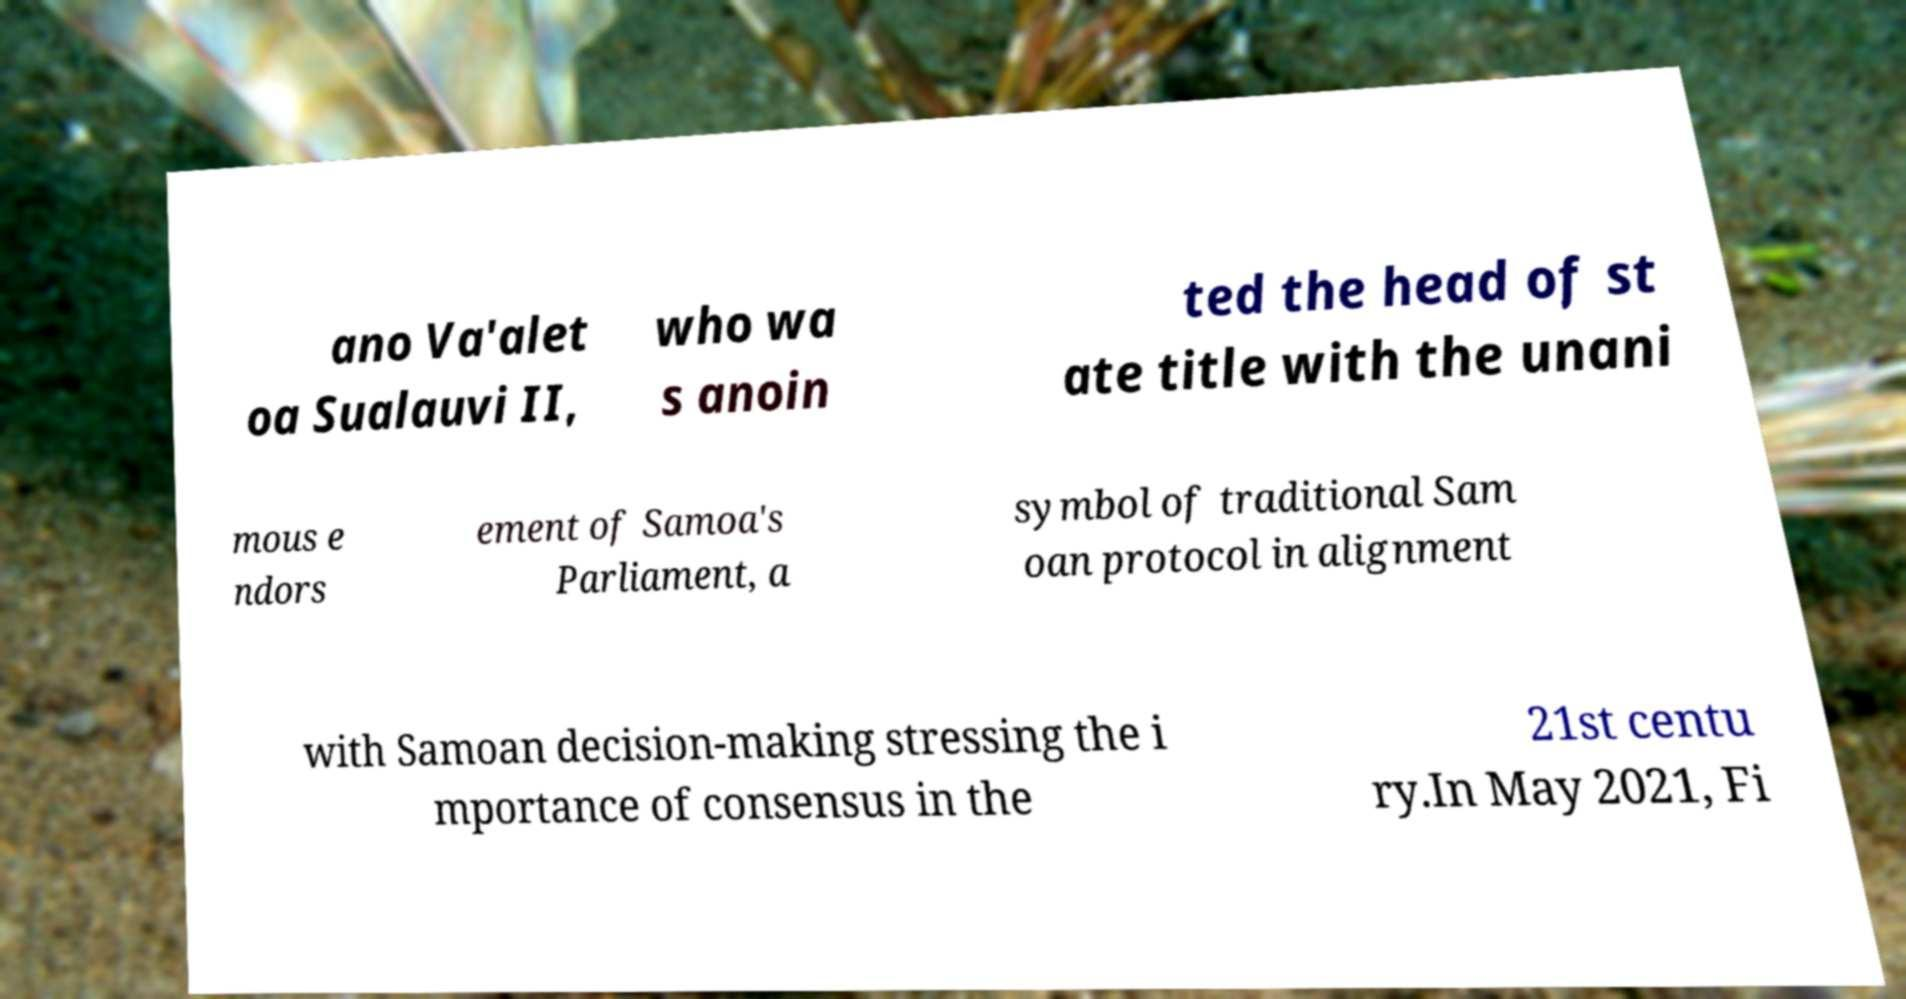What messages or text are displayed in this image? I need them in a readable, typed format. ano Va'alet oa Sualauvi II, who wa s anoin ted the head of st ate title with the unani mous e ndors ement of Samoa's Parliament, a symbol of traditional Sam oan protocol in alignment with Samoan decision-making stressing the i mportance of consensus in the 21st centu ry.In May 2021, Fi 